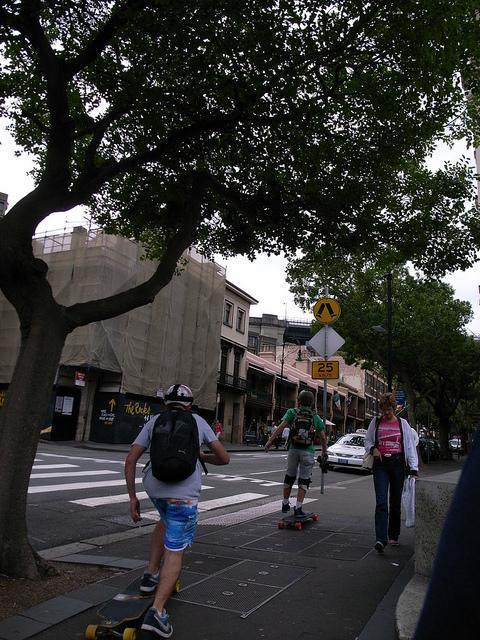How many people are not on skateboards?
Give a very brief answer. 1. How many street signs are there?
Give a very brief answer. 3. How many backpacks are there?
Give a very brief answer. 1. How many people are in the photo?
Give a very brief answer. 3. How many zebras are they?
Give a very brief answer. 0. 